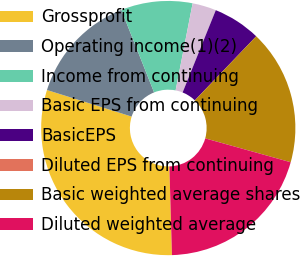<chart> <loc_0><loc_0><loc_500><loc_500><pie_chart><fcel>Grossprofit<fcel>Operating income(1)(2)<fcel>Income from continuing<fcel>Basic EPS from continuing<fcel>BasicEPS<fcel>Diluted EPS from continuing<fcel>Basic weighted average shares<fcel>Diluted weighted average<nl><fcel>30.3%<fcel>14.14%<fcel>9.09%<fcel>3.03%<fcel>6.06%<fcel>0.0%<fcel>17.17%<fcel>20.2%<nl></chart> 